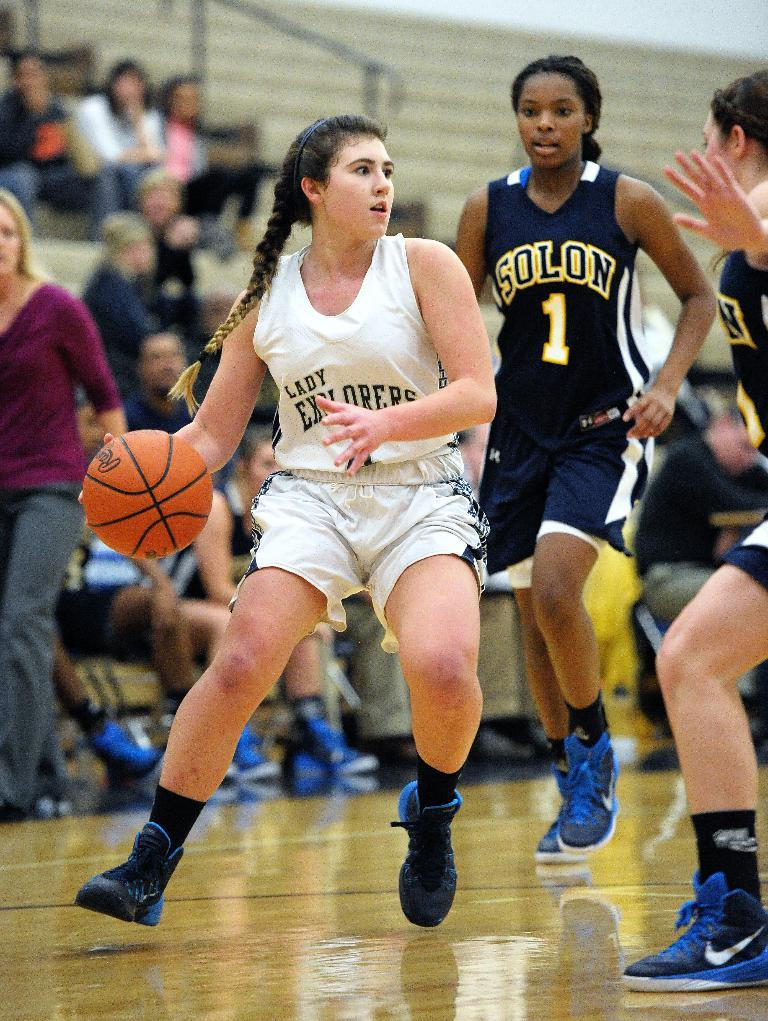Who is present in the image? There are women in the image. What are the women wearing? The women are wearing t-shirts and shorts. What activity are the women engaged in? The women are playing volleyball on the floor. What can be seen in the background of the image? There are people sitting on the stairs in the background. What type of watch is the woman wearing on her left hand? There is no watch visible on any of the women's hands in the image. 